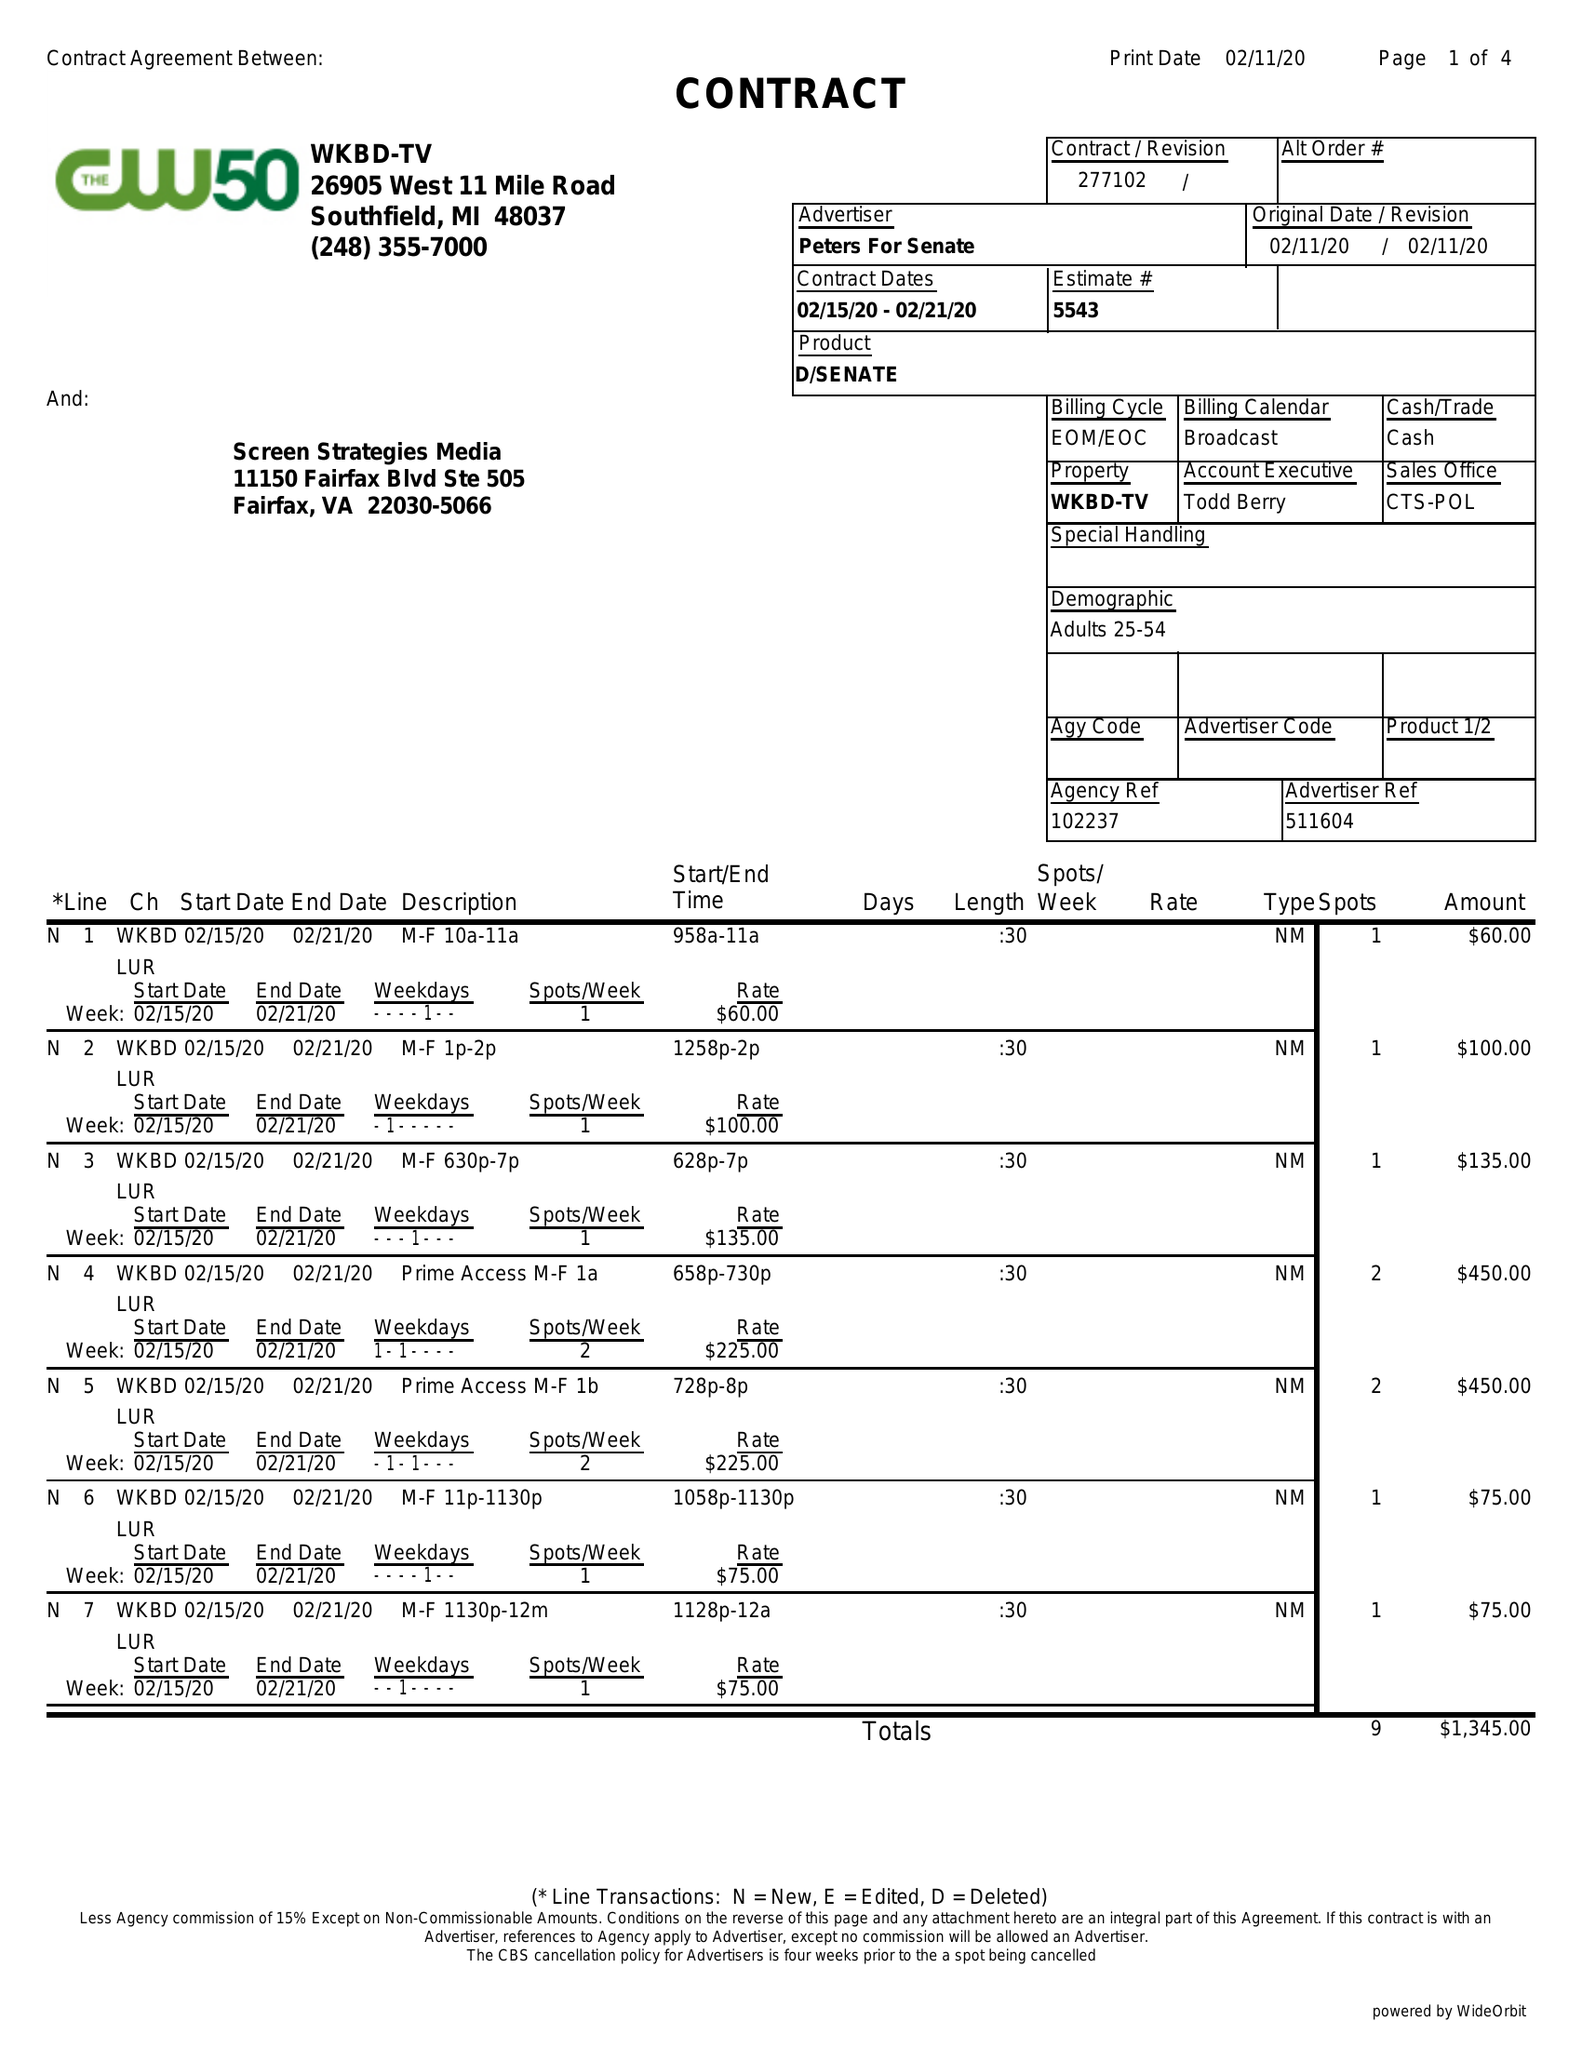What is the value for the contract_num?
Answer the question using a single word or phrase. 277102 